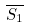Convert formula to latex. <formula><loc_0><loc_0><loc_500><loc_500>\overline { S _ { 1 } }</formula> 